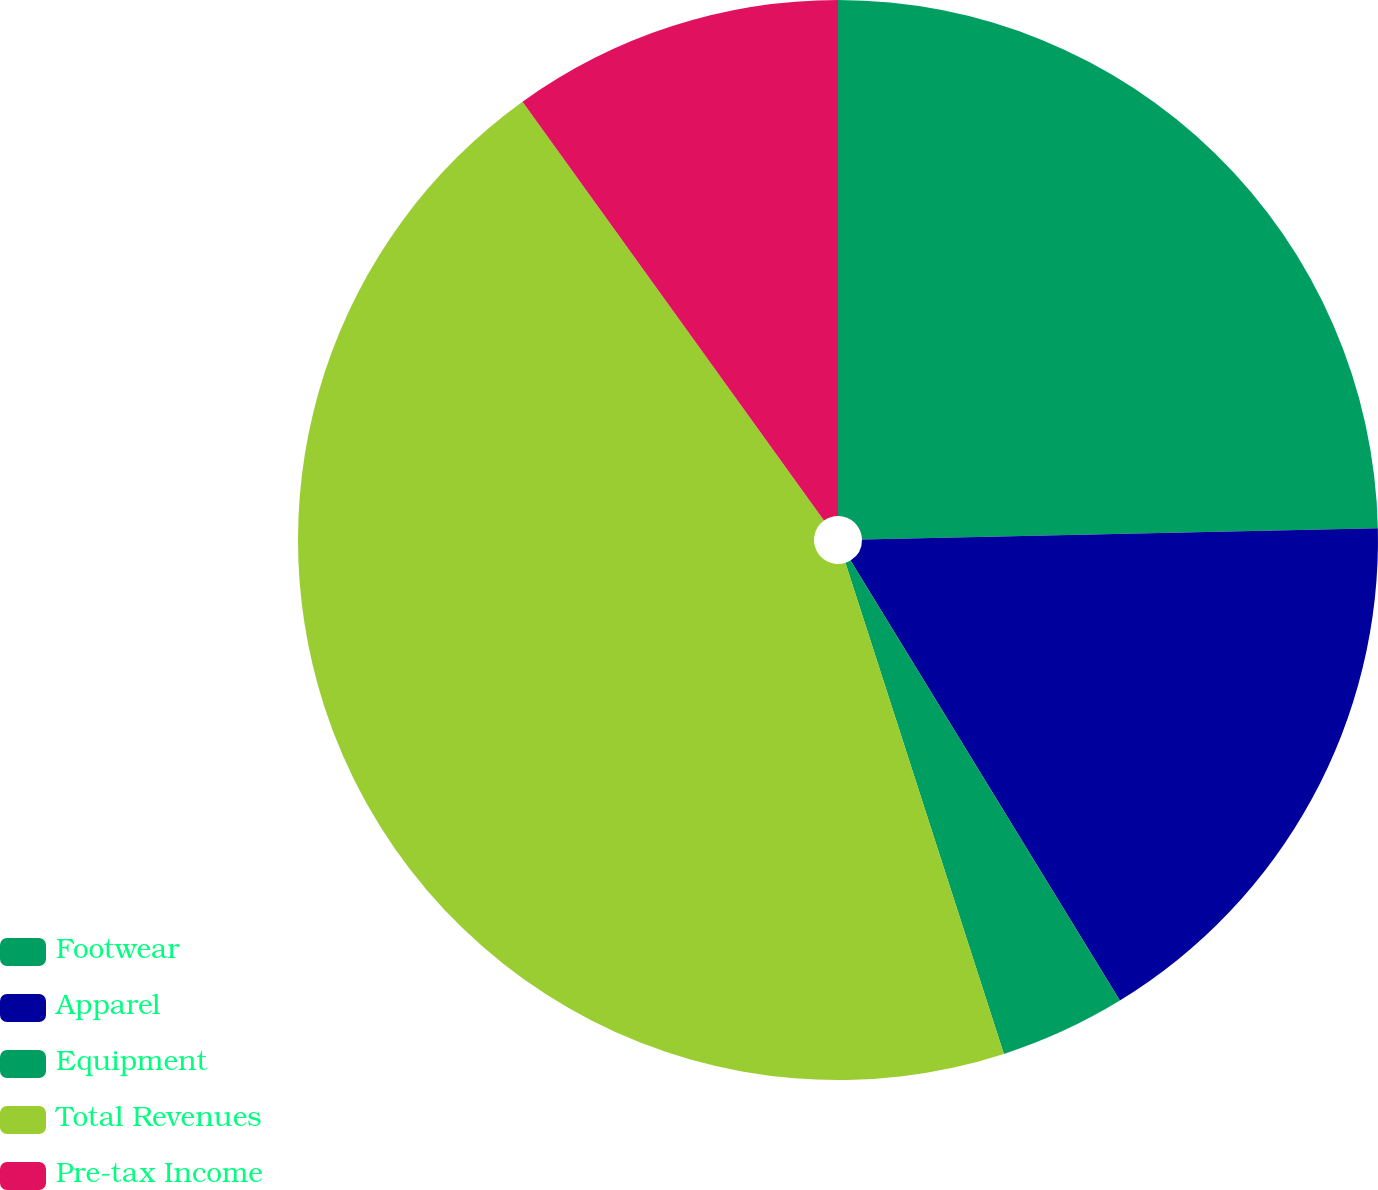<chart> <loc_0><loc_0><loc_500><loc_500><pie_chart><fcel>Footwear<fcel>Apparel<fcel>Equipment<fcel>Total Revenues<fcel>Pre-tax Income<nl><fcel>24.65%<fcel>16.61%<fcel>3.77%<fcel>45.04%<fcel>9.93%<nl></chart> 